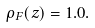Convert formula to latex. <formula><loc_0><loc_0><loc_500><loc_500>\rho _ { F } ( z ) = 1 . 0 .</formula> 